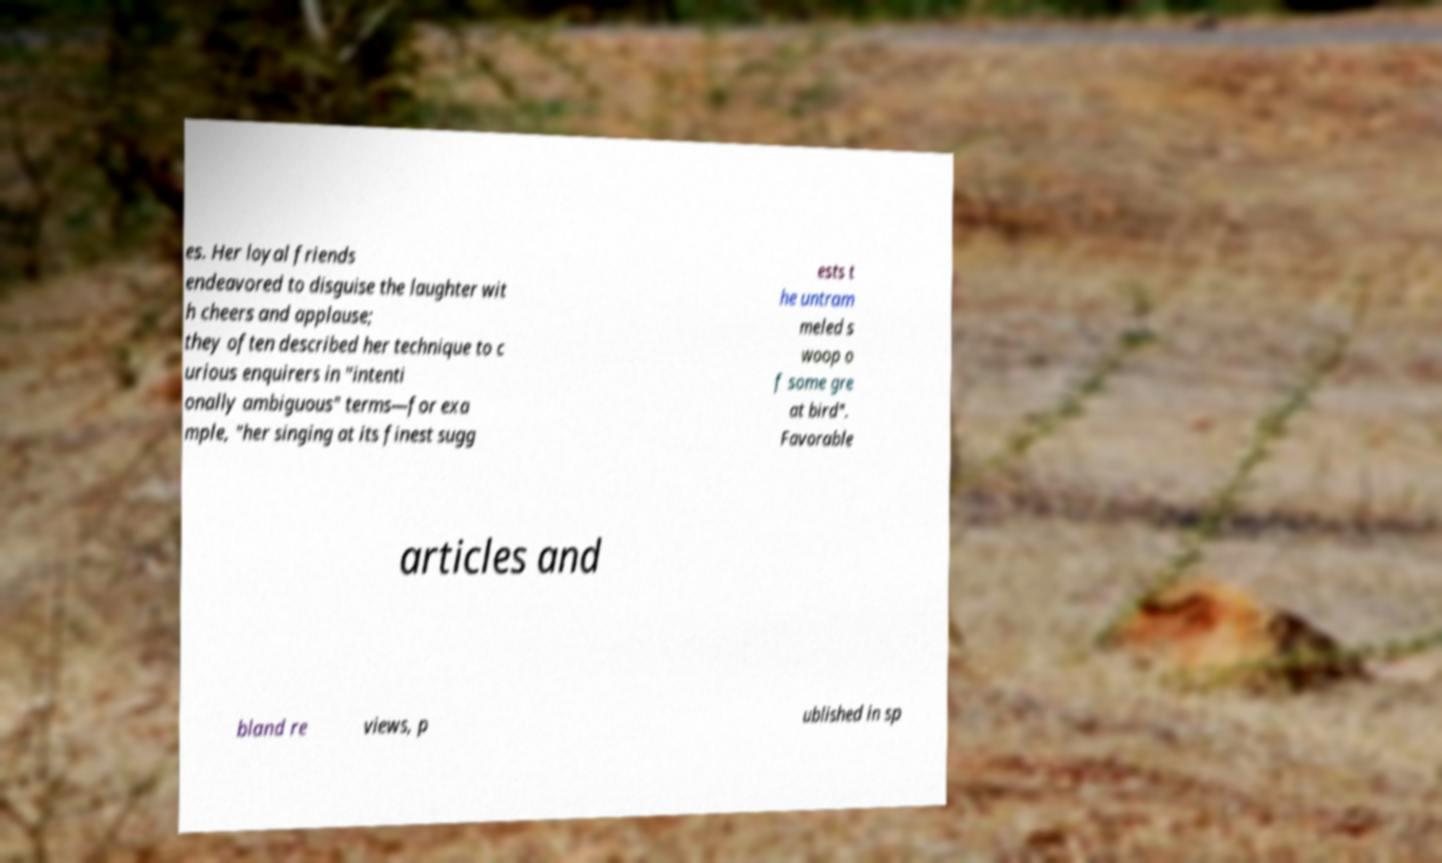For documentation purposes, I need the text within this image transcribed. Could you provide that? es. Her loyal friends endeavored to disguise the laughter wit h cheers and applause; they often described her technique to c urious enquirers in "intenti onally ambiguous" terms—for exa mple, "her singing at its finest sugg ests t he untram meled s woop o f some gre at bird". Favorable articles and bland re views, p ublished in sp 